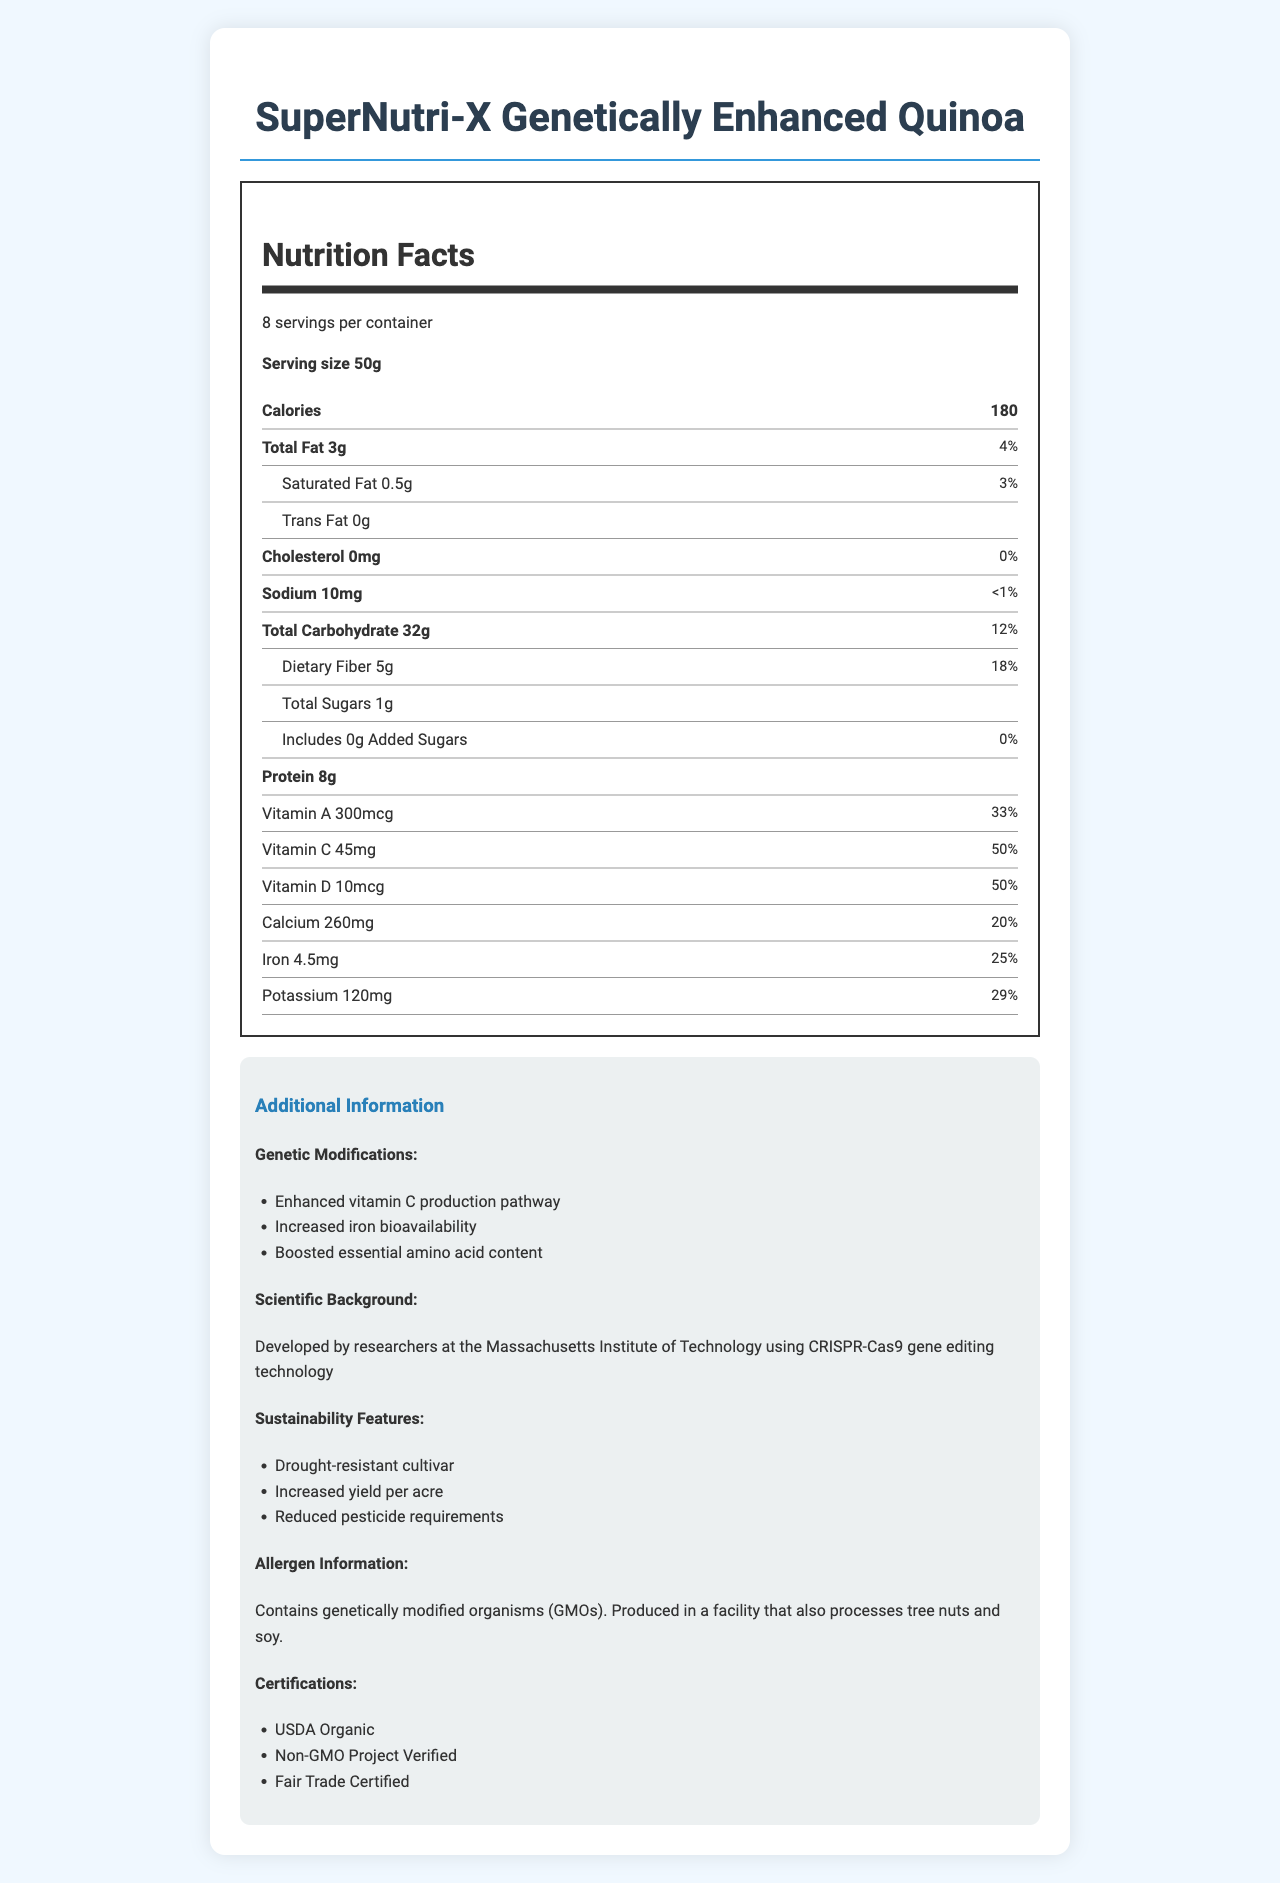What is the serving size of SuperNutri-X Genetically Enhanced Quinoa? The serving size is clearly stated on the label as "Serving size 50g".
Answer: 50g How many calories are in one serving? The nutrition label indicates that there are 180 calories per serving.
Answer: 180 How much protein is in one serving? The amount of protein per serving is specified as 8g on the nutrition label.
Answer: 8g What percentage of the daily value of Vitamin C does one serving provide? The label indicates that one serving provides 50% of the daily value of Vitamin C.
Answer: 50% What is the total fat content per serving? The label clearly states that the total fat content per serving is 3g.
Answer: 3g Which vitamin is present at 100% daily value in the highest amount per serving? A. Vitamin E B. Vitamin K C. Thiamin D. Riboflavin The label shows that Vitamin E is 15mg, marking 100% daily value, which is the highest among the vitamins present at 100%.
Answer: A. Vitamin E How much calcium is in one serving? A. 250 mg B. 260 mg C. 270 mg D. 280 mg The label states that each serving contains 260 mg of calcium, which is 20% of the daily value.
Answer: B. 260 mg Does the product contain added sugars? The label states that there are 0g of added sugars in the product.
Answer: No Is the product USDA Organic certified? The additional information section of the document lists USDA Organic as one of the certifications.
Answer: Yes Describe the sustainability features of SuperNutri-X Genetically Enhanced Quinoa. The additional information section highlights these three sustainability features: drought-resistant cultivar, increased yield per acre, and reduced pesticide requirements.
Answer: Drought-resistant cultivar, increased yield per acre, reduced pesticide requirements What scientific technology was used to develop SuperNutri-X Genetically Enhanced Quinoa? The scientific background information states that the product was developed using CRISPR-Cas9 gene editing technology.
Answer: CRISPR-Cas9 gene editing technology What is one of the genetic modifications mentioned for SuperNutri-X? The additional information lists "Enhanced vitamin C production pathway" as one of the genetic modifications.
Answer: Enhanced vitamin C production pathway How much dietary fiber is in one serving, and what is the daily value percentage? The label indicates that one serving contains 5g of dietary fiber, which is 18% of the daily value.
Answer: 5g, 18% Does the product contain any cholesterol? The label mentions that there is 0mg of cholesterol in the product, which is 0% of the daily value.
Answer: No Can you determine if the SuperNutri-X is gluten-free? The document does not provide any information regarding whether SuperNutri-X is gluten-free or not.
Answer: Cannot be determined What are the main modifications made to the SuperNutri-X? According to the additional information section, these are the key genetic modifications made to the product.
Answer: Enhanced vitamin C production pathway, increased iron bioavailability, boosted essential amino acid content 